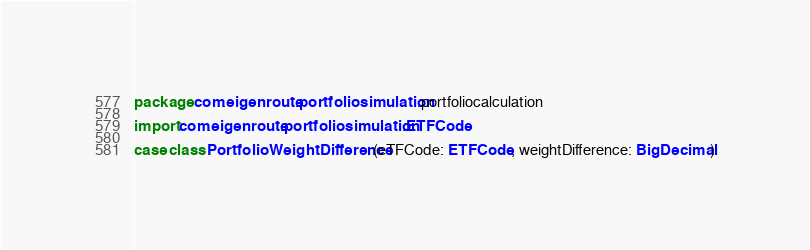Convert code to text. <code><loc_0><loc_0><loc_500><loc_500><_Scala_>package com.eigenroute.portfoliosimulation.portfoliocalculation

import com.eigenroute.portfoliosimulation.ETFCode

case class PortfolioWeightDifference(eTFCode: ETFCode, weightDifference: BigDecimal)
</code> 